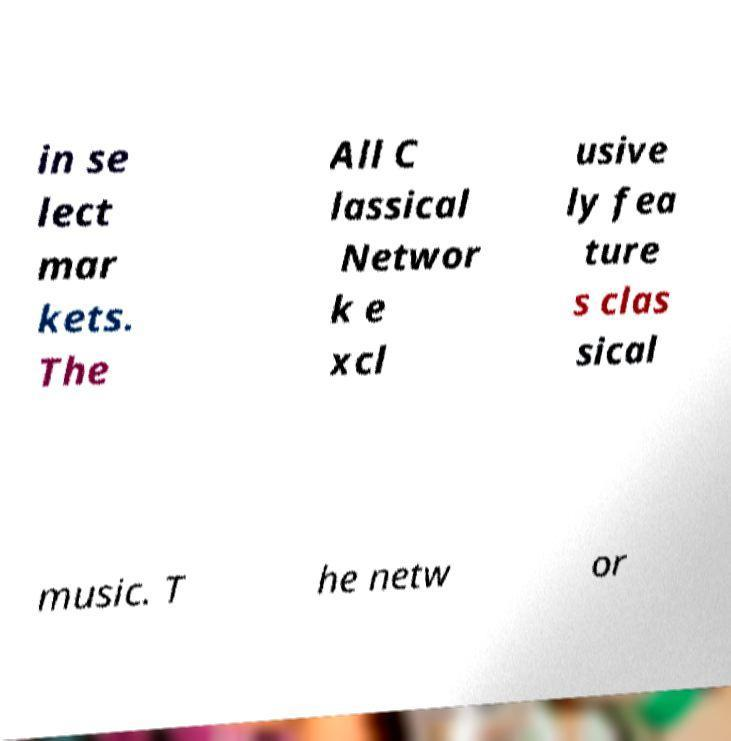Please identify and transcribe the text found in this image. in se lect mar kets. The All C lassical Networ k e xcl usive ly fea ture s clas sical music. T he netw or 